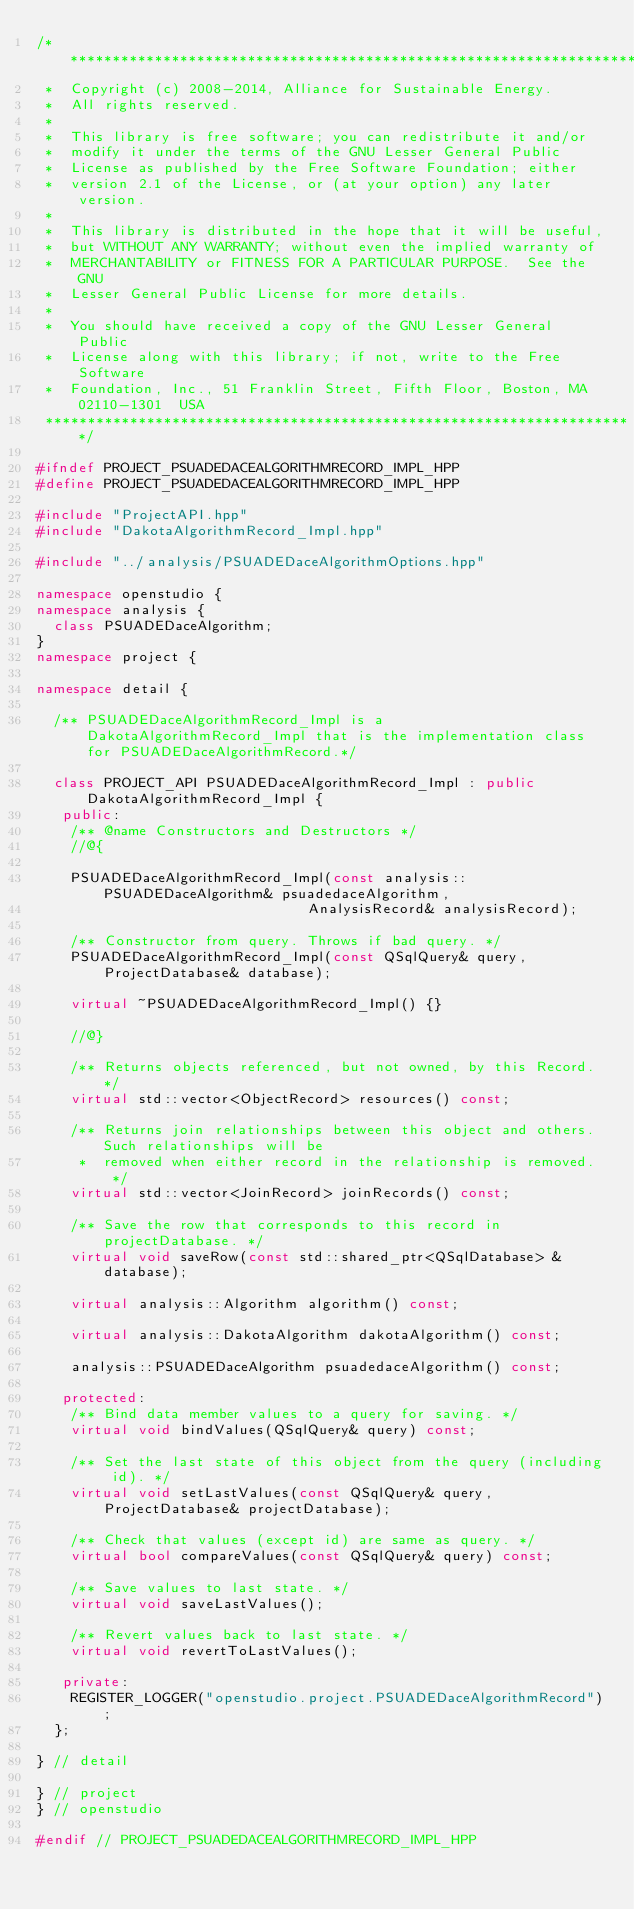<code> <loc_0><loc_0><loc_500><loc_500><_C++_>/**********************************************************************
 *  Copyright (c) 2008-2014, Alliance for Sustainable Energy.
 *  All rights reserved.
 *
 *  This library is free software; you can redistribute it and/or
 *  modify it under the terms of the GNU Lesser General Public
 *  License as published by the Free Software Foundation; either
 *  version 2.1 of the License, or (at your option) any later version.
 *
 *  This library is distributed in the hope that it will be useful,
 *  but WITHOUT ANY WARRANTY; without even the implied warranty of
 *  MERCHANTABILITY or FITNESS FOR A PARTICULAR PURPOSE.  See the GNU
 *  Lesser General Public License for more details.
 *
 *  You should have received a copy of the GNU Lesser General Public
 *  License along with this library; if not, write to the Free Software
 *  Foundation, Inc., 51 Franklin Street, Fifth Floor, Boston, MA  02110-1301  USA
 **********************************************************************/

#ifndef PROJECT_PSUADEDACEALGORITHMRECORD_IMPL_HPP
#define PROJECT_PSUADEDACEALGORITHMRECORD_IMPL_HPP

#include "ProjectAPI.hpp"
#include "DakotaAlgorithmRecord_Impl.hpp"

#include "../analysis/PSUADEDaceAlgorithmOptions.hpp"

namespace openstudio {
namespace analysis {
  class PSUADEDaceAlgorithm;
}
namespace project {

namespace detail {

  /** PSUADEDaceAlgorithmRecord_Impl is a DakotaAlgorithmRecord_Impl that is the implementation class for PSUADEDaceAlgorithmRecord.*/

  class PROJECT_API PSUADEDaceAlgorithmRecord_Impl : public DakotaAlgorithmRecord_Impl {
   public:
    /** @name Constructors and Destructors */
    //@{

    PSUADEDaceAlgorithmRecord_Impl(const analysis::PSUADEDaceAlgorithm& psuadedaceAlgorithm,
                                AnalysisRecord& analysisRecord);

    /** Constructor from query. Throws if bad query. */
    PSUADEDaceAlgorithmRecord_Impl(const QSqlQuery& query, ProjectDatabase& database);

    virtual ~PSUADEDaceAlgorithmRecord_Impl() {}

    //@}

    /** Returns objects referenced, but not owned, by this Record. */
    virtual std::vector<ObjectRecord> resources() const;

    /** Returns join relationships between this object and others. Such relationships will be 
     *  removed when either record in the relationship is removed. */
    virtual std::vector<JoinRecord> joinRecords() const;

    /** Save the row that corresponds to this record in projectDatabase. */
    virtual void saveRow(const std::shared_ptr<QSqlDatabase> &database);

    virtual analysis::Algorithm algorithm() const;

    virtual analysis::DakotaAlgorithm dakotaAlgorithm() const;

    analysis::PSUADEDaceAlgorithm psuadedaceAlgorithm() const;

   protected:
    /** Bind data member values to a query for saving. */
    virtual void bindValues(QSqlQuery& query) const;

    /** Set the last state of this object from the query (including id). */
    virtual void setLastValues(const QSqlQuery& query, ProjectDatabase& projectDatabase);

    /** Check that values (except id) are same as query. */
    virtual bool compareValues(const QSqlQuery& query) const;

    /** Save values to last state. */
    virtual void saveLastValues();

    /** Revert values back to last state. */
    virtual void revertToLastValues();

   private:
    REGISTER_LOGGER("openstudio.project.PSUADEDaceAlgorithmRecord");
  };

} // detail

} // project
} // openstudio

#endif // PROJECT_PSUADEDACEALGORITHMRECORD_IMPL_HPP

</code> 